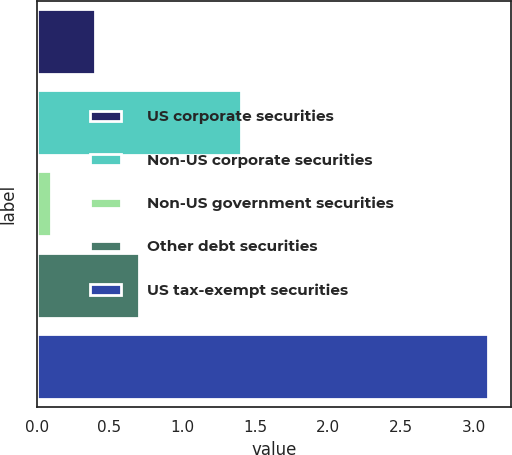Convert chart to OTSL. <chart><loc_0><loc_0><loc_500><loc_500><bar_chart><fcel>US corporate securities<fcel>Non-US corporate securities<fcel>Non-US government securities<fcel>Other debt securities<fcel>US tax-exempt securities<nl><fcel>0.4<fcel>1.4<fcel>0.1<fcel>0.7<fcel>3.1<nl></chart> 